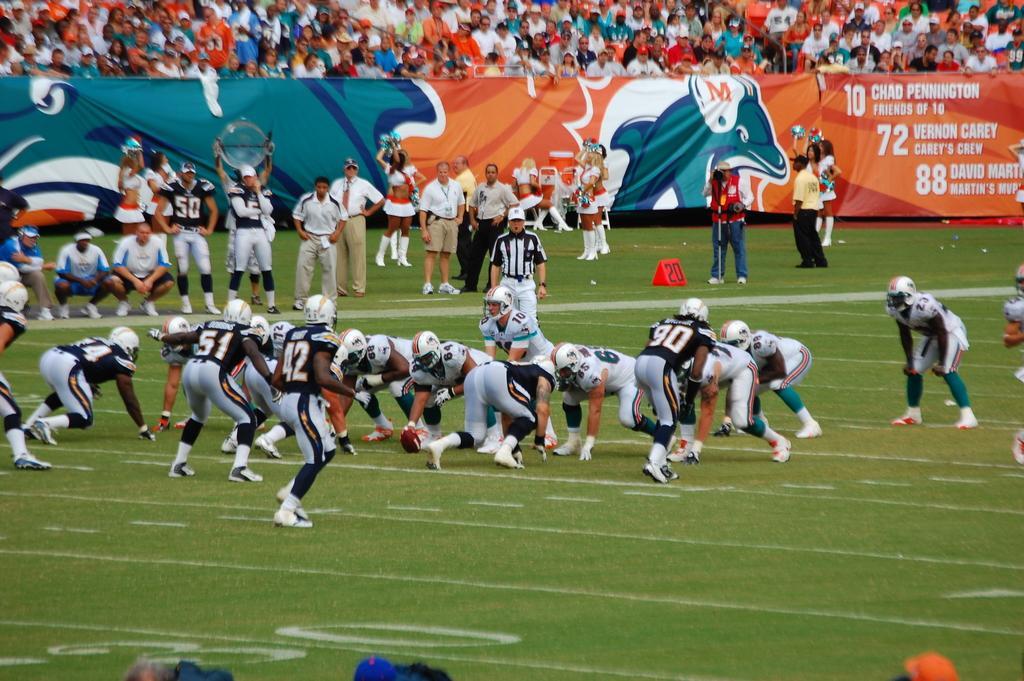Describe this image in one or two sentences. In this picture I can see few people are playing on the ground, side I can see the banner and few people are sitting and watching. 